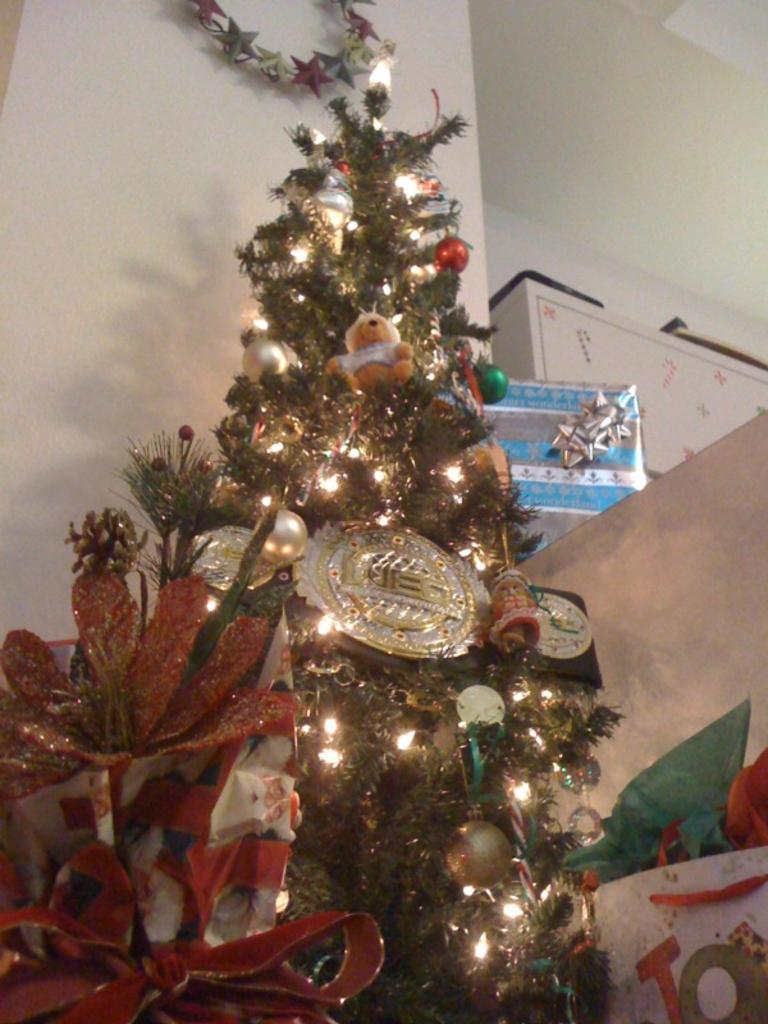What is the main object in the image? There is a Christmas tree in the image. What features can be seen on the Christmas tree? The Christmas tree has lights and decorative balls. What can be seen in the background of the image? There is a wall, boxes, and other objects visible in the background of the image. What is the value of the experience gained from visiting the airport in the image? There is no airport present in the image, so it is not possible to determine the value of any experience gained from visiting one. 